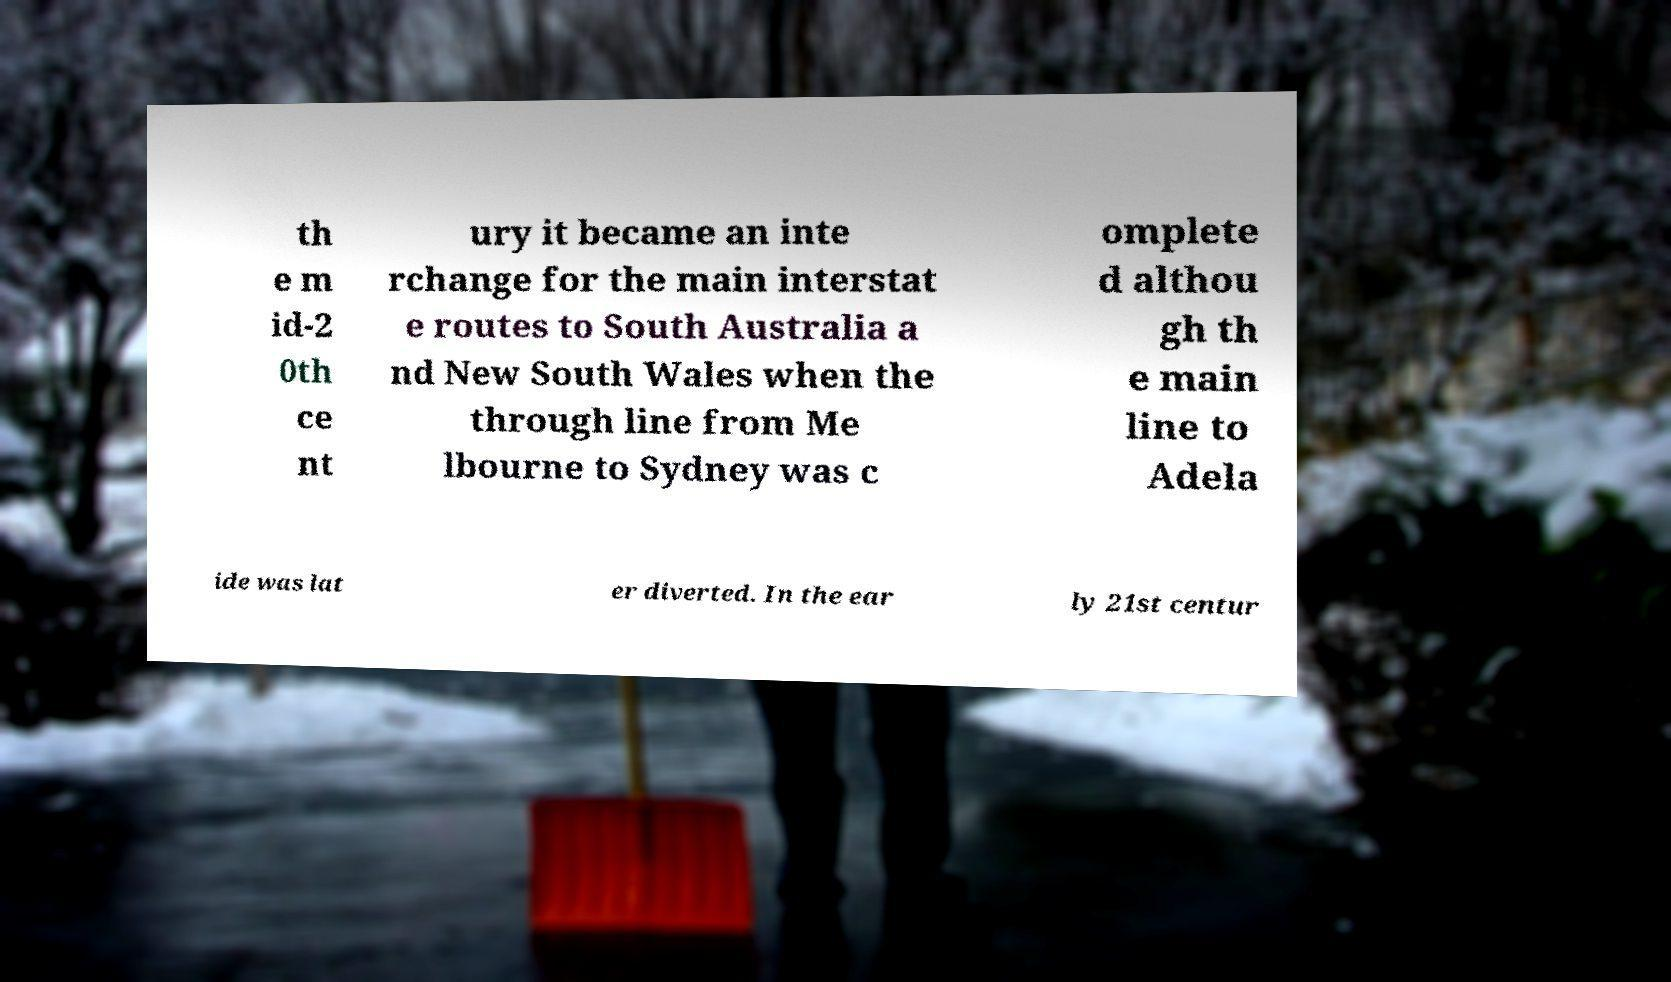Can you read and provide the text displayed in the image?This photo seems to have some interesting text. Can you extract and type it out for me? th e m id-2 0th ce nt ury it became an inte rchange for the main interstat e routes to South Australia a nd New South Wales when the through line from Me lbourne to Sydney was c omplete d althou gh th e main line to Adela ide was lat er diverted. In the ear ly 21st centur 